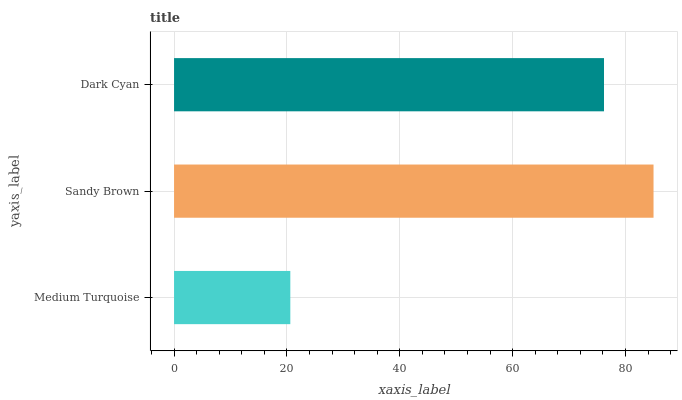Is Medium Turquoise the minimum?
Answer yes or no. Yes. Is Sandy Brown the maximum?
Answer yes or no. Yes. Is Dark Cyan the minimum?
Answer yes or no. No. Is Dark Cyan the maximum?
Answer yes or no. No. Is Sandy Brown greater than Dark Cyan?
Answer yes or no. Yes. Is Dark Cyan less than Sandy Brown?
Answer yes or no. Yes. Is Dark Cyan greater than Sandy Brown?
Answer yes or no. No. Is Sandy Brown less than Dark Cyan?
Answer yes or no. No. Is Dark Cyan the high median?
Answer yes or no. Yes. Is Dark Cyan the low median?
Answer yes or no. Yes. Is Medium Turquoise the high median?
Answer yes or no. No. Is Medium Turquoise the low median?
Answer yes or no. No. 